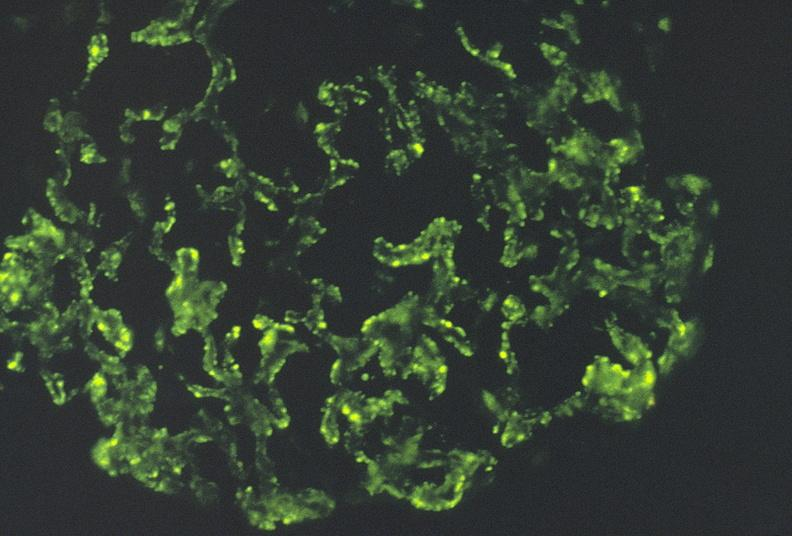s urinary present?
Answer the question using a single word or phrase. Yes 